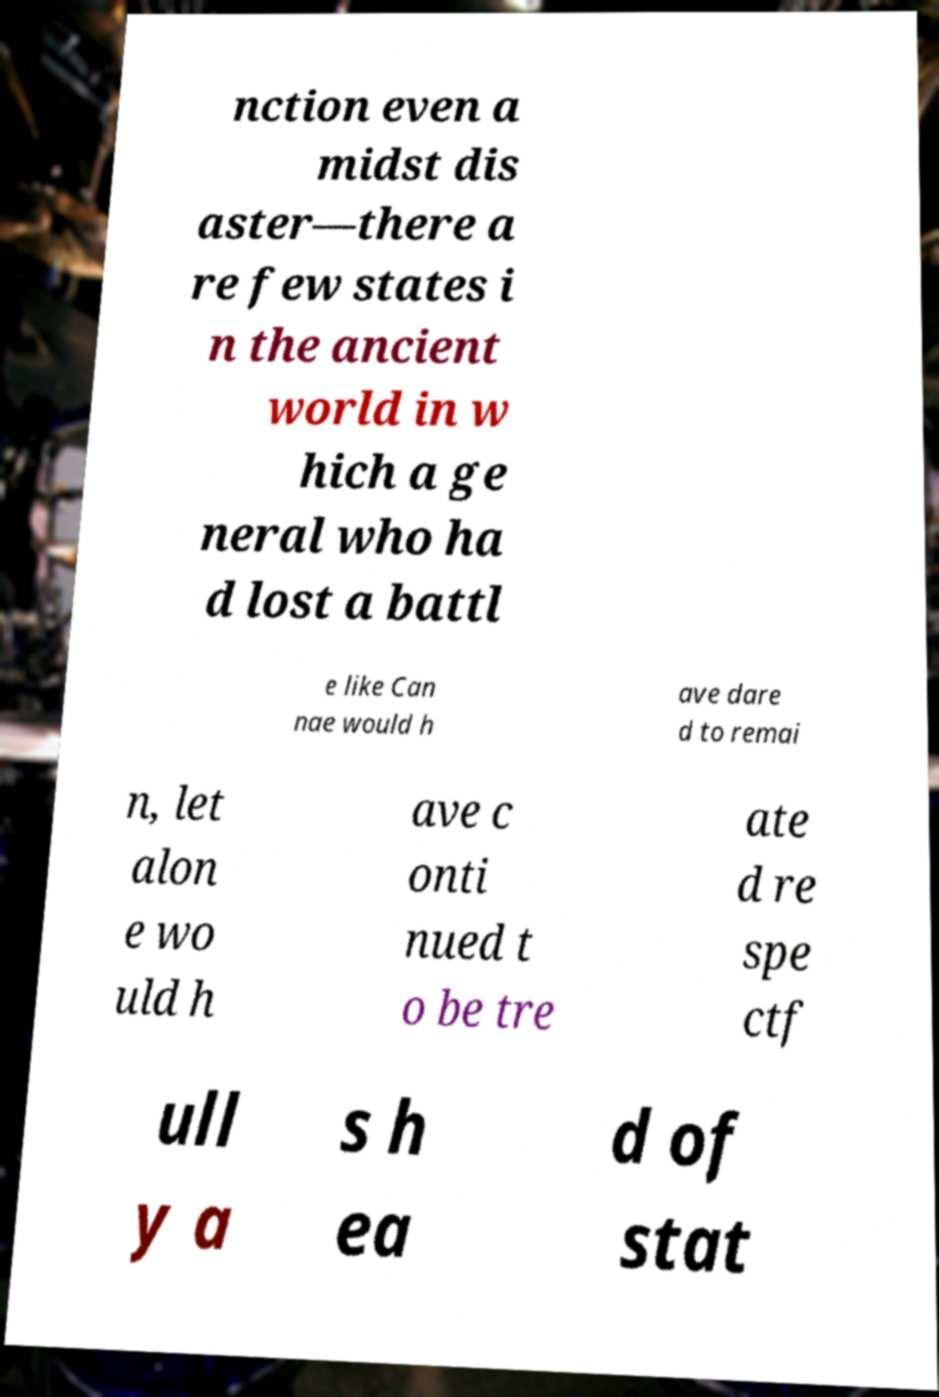I need the written content from this picture converted into text. Can you do that? nction even a midst dis aster—there a re few states i n the ancient world in w hich a ge neral who ha d lost a battl e like Can nae would h ave dare d to remai n, let alon e wo uld h ave c onti nued t o be tre ate d re spe ctf ull y a s h ea d of stat 